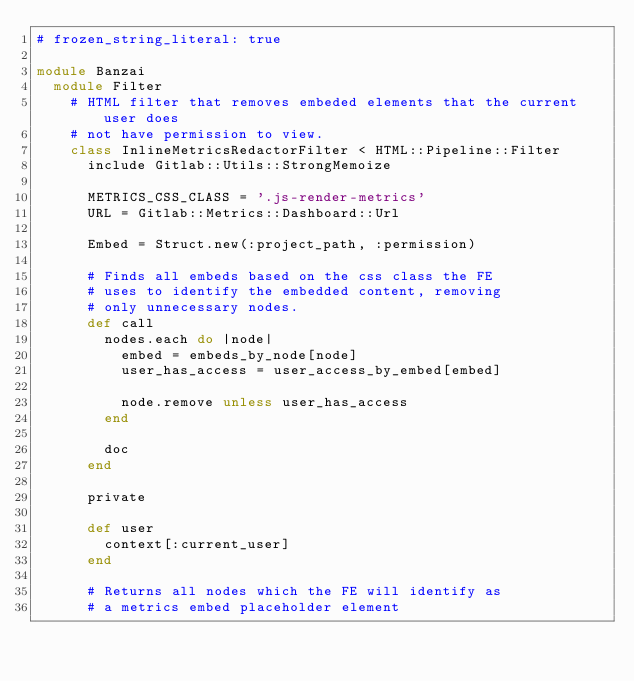Convert code to text. <code><loc_0><loc_0><loc_500><loc_500><_Ruby_># frozen_string_literal: true

module Banzai
  module Filter
    # HTML filter that removes embeded elements that the current user does
    # not have permission to view.
    class InlineMetricsRedactorFilter < HTML::Pipeline::Filter
      include Gitlab::Utils::StrongMemoize

      METRICS_CSS_CLASS = '.js-render-metrics'
      URL = Gitlab::Metrics::Dashboard::Url

      Embed = Struct.new(:project_path, :permission)

      # Finds all embeds based on the css class the FE
      # uses to identify the embedded content, removing
      # only unnecessary nodes.
      def call
        nodes.each do |node|
          embed = embeds_by_node[node]
          user_has_access = user_access_by_embed[embed]

          node.remove unless user_has_access
        end

        doc
      end

      private

      def user
        context[:current_user]
      end

      # Returns all nodes which the FE will identify as
      # a metrics embed placeholder element</code> 